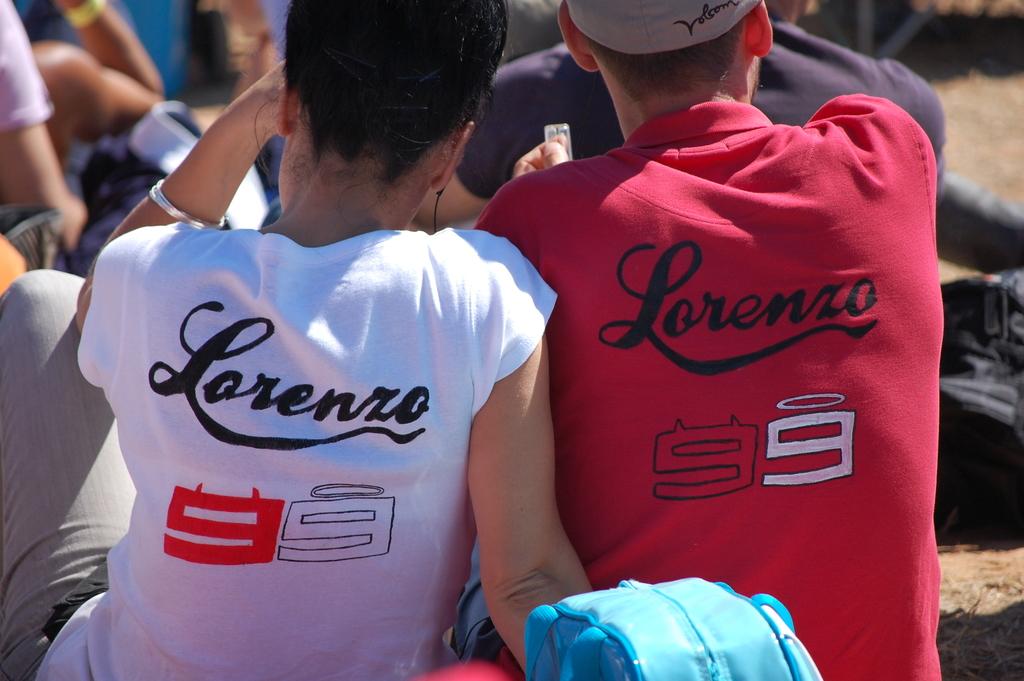What is the name of player 99?
Provide a succinct answer. Lorenzo. 